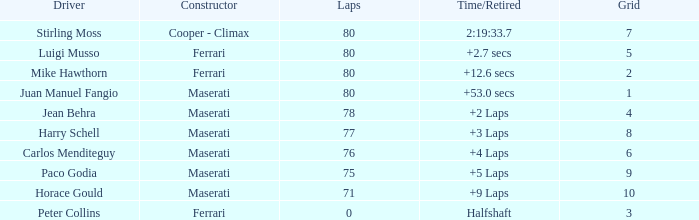What's the average Grid for a Maserati with less than 80 laps, and a Time/Retired of +2 laps? 4.0. 